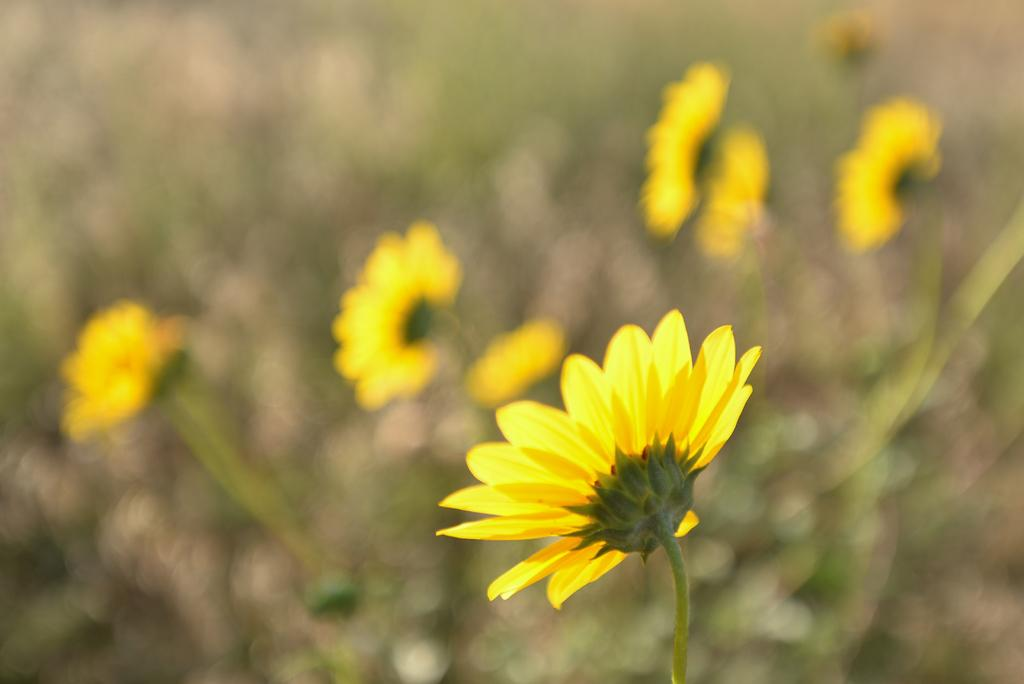What type of plants can be seen in the image? There are plants with flowers in the image. Can you describe the background of the image? The background of the image is blurred. What type of glue is being used by the farmer in the image? There is no farmer or glue present in the image; it features plants with flowers and a blurred background. 